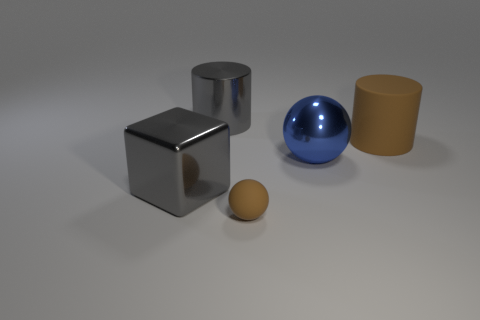There is a ball that is the same color as the big matte object; what is its material?
Your response must be concise. Rubber. Is the size of the gray cylinder the same as the gray metal cube?
Your answer should be compact. Yes. There is a rubber thing in front of the brown matte thing that is right of the tiny brown object; what is its size?
Your response must be concise. Small. Does the big shiny cylinder have the same color as the big metallic object that is to the right of the small matte thing?
Your response must be concise. No. Are there any brown balls of the same size as the blue sphere?
Your answer should be very brief. No. There is a ball that is behind the brown sphere; how big is it?
Offer a terse response. Large. There is a large gray cylinder that is to the left of the tiny brown matte sphere; is there a large brown rubber cylinder that is in front of it?
Your answer should be very brief. Yes. What number of other things are there of the same shape as the small brown matte object?
Provide a short and direct response. 1. Is the tiny brown rubber object the same shape as the big blue thing?
Provide a short and direct response. Yes. There is a large thing that is both on the right side of the block and on the left side of the blue thing; what color is it?
Keep it short and to the point. Gray. 